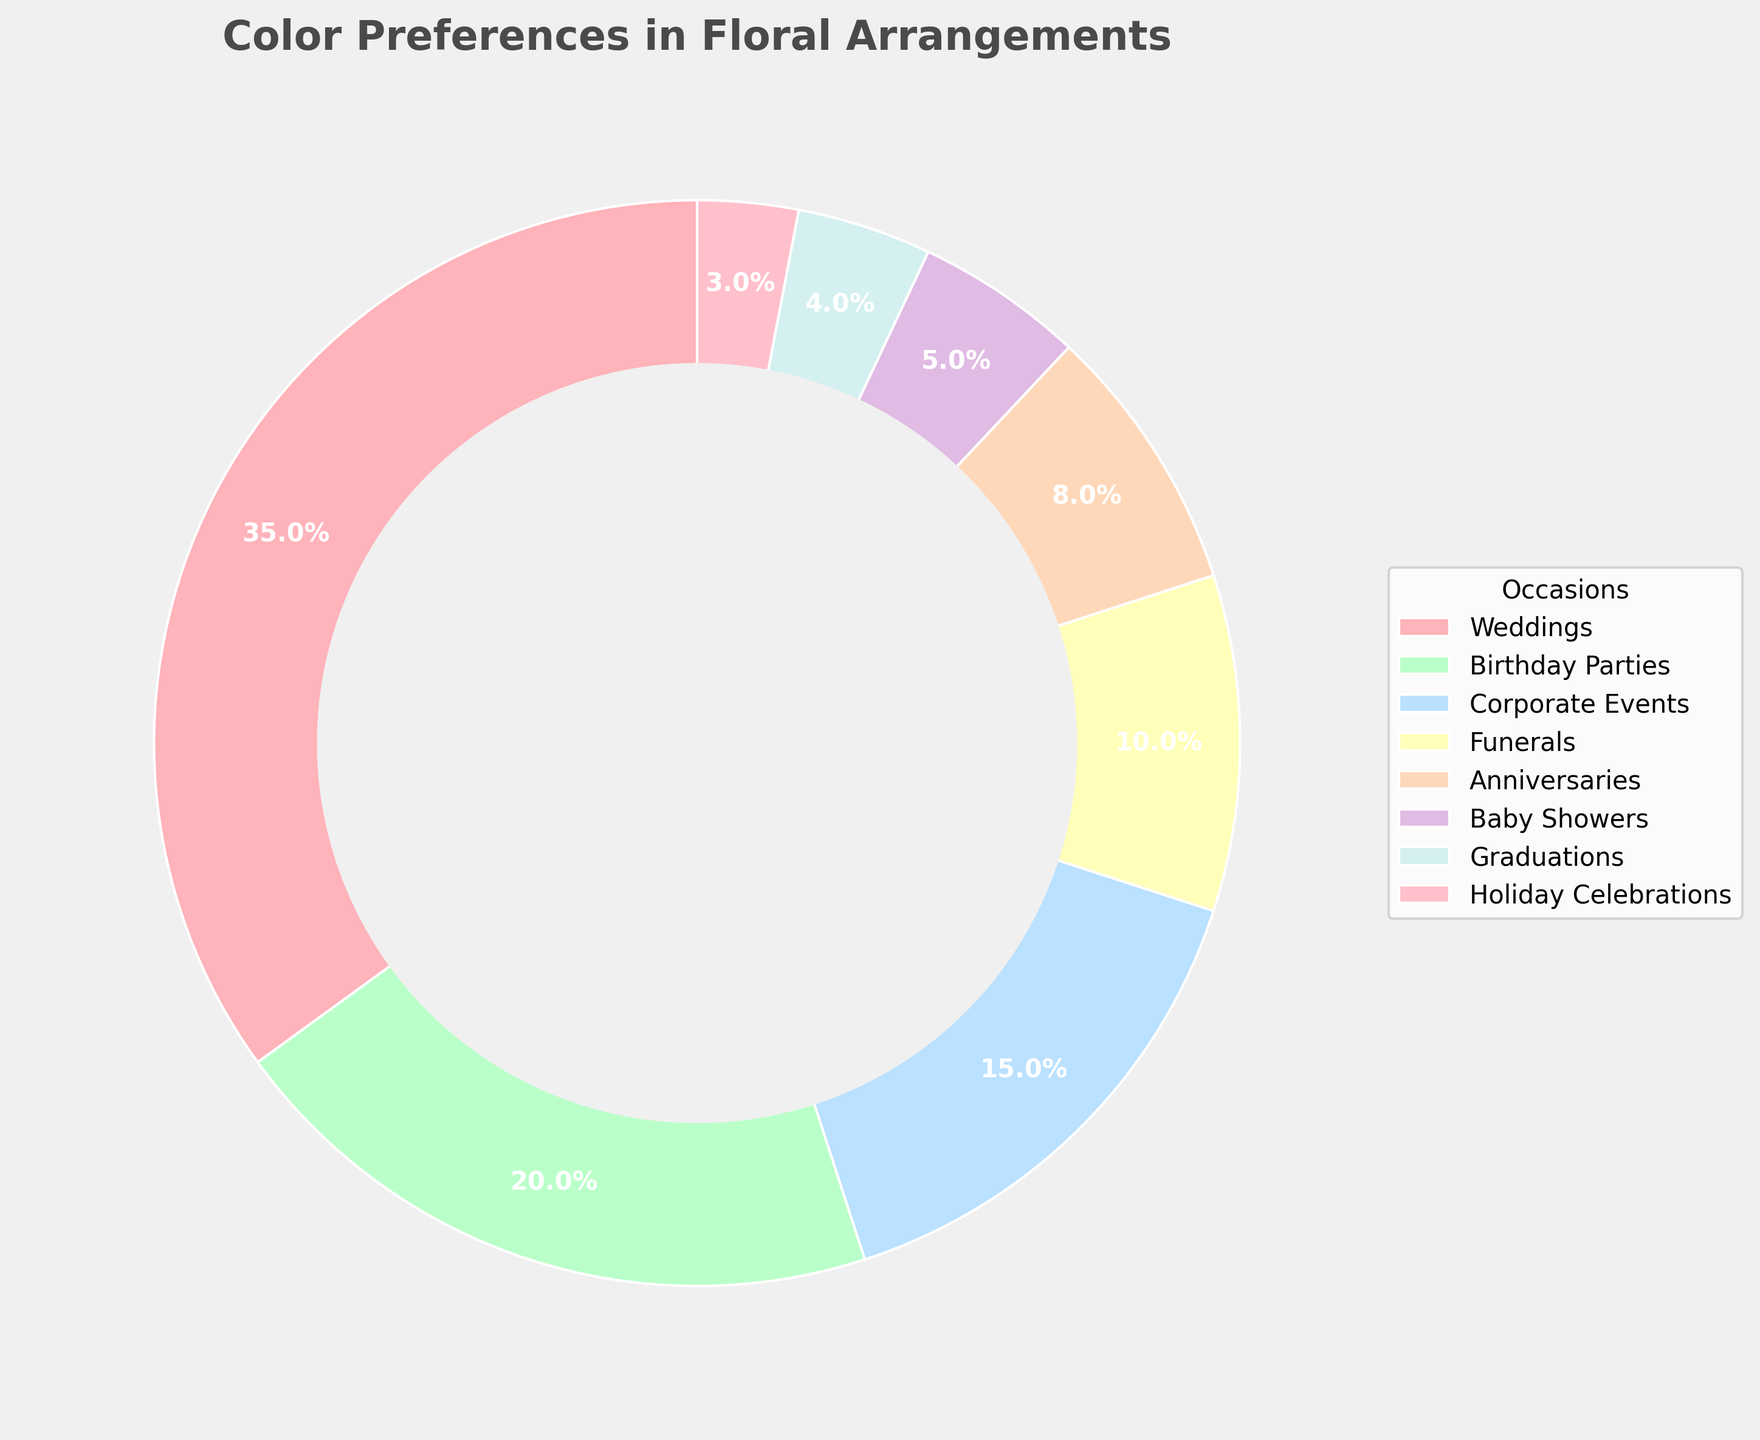What is the most preferred color for weddings and what percentage does it hold? Weddings have the highest preference at 35%. By inspecting the figure, we see that the largest segment corresponds to weddings with 35%.
Answer: 35% Which occasion has the second-highest color preference and what percentage is it? After weddings, birthday parties have the second-highest preference. Observing the sizes of the segments, we find the one labeled 'Birthday Parties' at 20%.
Answer: 20% How many occasions have a color preference percentage lower than 10%? By inspecting the figure, add up the segments with percentages below 10%. Funerals (10%) don't meet the criteria. Anniversaries (8%), Baby Showers (5%), Graduations (4%), Holiday Celebrations (3%) do. That's four occasions.
Answer: 4 What is the total percentage of color preferences for corporate events and funerals combined? First, locate corporate events and funerals in the figure and note their percentages (15% + 10%). Adding these together gives us 25%.
Answer: 25% Which occasion has the smallest slice in the pie chart, and what is the corresponding percentage? The occasion with the smallest slice can be found visually at the narrowest part of the pie. 'Holiday Celebrations' has the smallest with 3%.
Answer: 3% Is the color preference for anniversaries greater than the color preference for baby showers? By checking both segments in the pie chart, we compare anniversaries (8%) and baby showers (5%). Anniversaries have a greater percentage.
Answer: Yes How does the color preference for birthday parties compare to the sum of the preferences for graduations and baby showers? Look at the percentages: birthday parties (20%), graduations (4%), baby showers (5%). Sum graduations and baby showers (4% + 5% = 9%). Birthday parties' percentage (20%) is greater than this sum (9%).
Answer: Greater What’s the difference in color preference between weddings and corporate events? From the pie chart, weddings hold 35% and corporate events 15%. Subtract the two (35% - 15% = 20%).
Answer: 20% Which occasion has a color preference percentage twice that of graduations? Graduation has 4%. Finding an occasion with 2 x 4% = 8%, we observe 'Anniversaries' which has 8%.
Answer: Anniversaries What's the combined color preference for baby showers, graduations, and holiday celebrations? Locate the percentages for these occasions: baby showers 5%, graduations 4%, holiday celebrations 3%. Summing them (5% + 4% + 3% = 12%).
Answer: 12% 